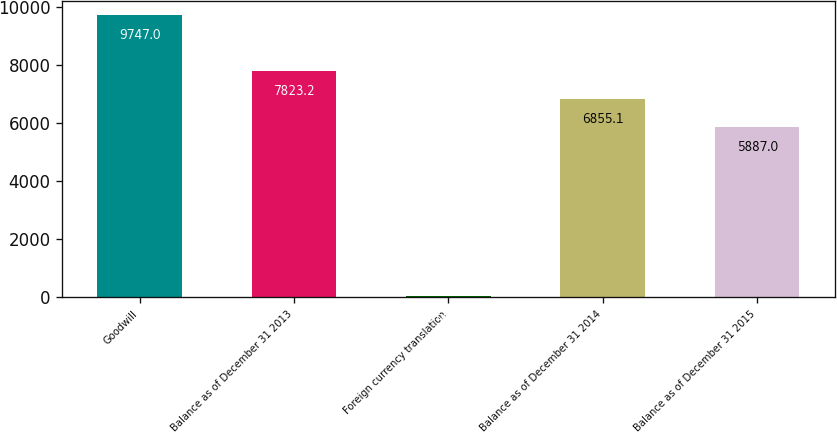Convert chart. <chart><loc_0><loc_0><loc_500><loc_500><bar_chart><fcel>Goodwill<fcel>Balance as of December 31 2013<fcel>Foreign currency translation<fcel>Balance as of December 31 2014<fcel>Balance as of December 31 2015<nl><fcel>9747<fcel>7823.2<fcel>66<fcel>6855.1<fcel>5887<nl></chart> 